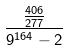Convert formula to latex. <formula><loc_0><loc_0><loc_500><loc_500>\frac { \frac { 4 0 6 } { 2 7 7 } } { 9 ^ { 1 6 4 } - 2 }</formula> 